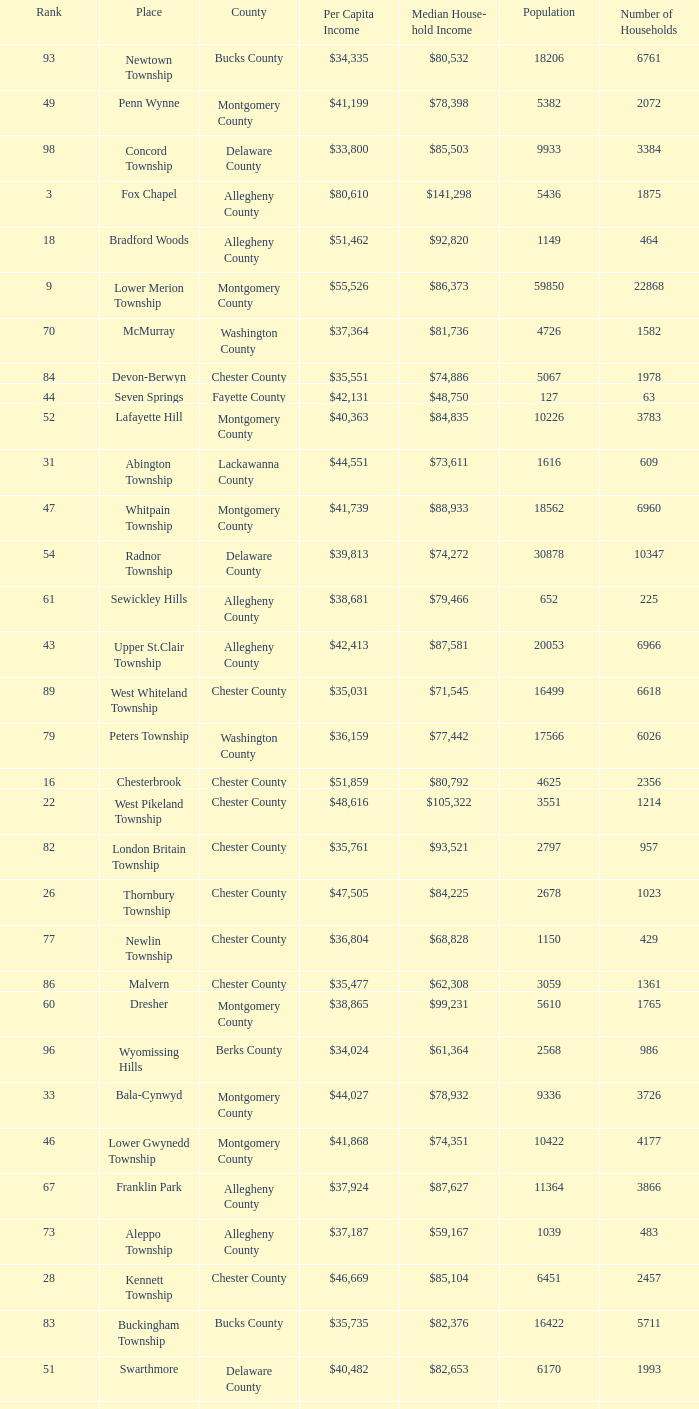What county has 2053 households?  Chester County. 